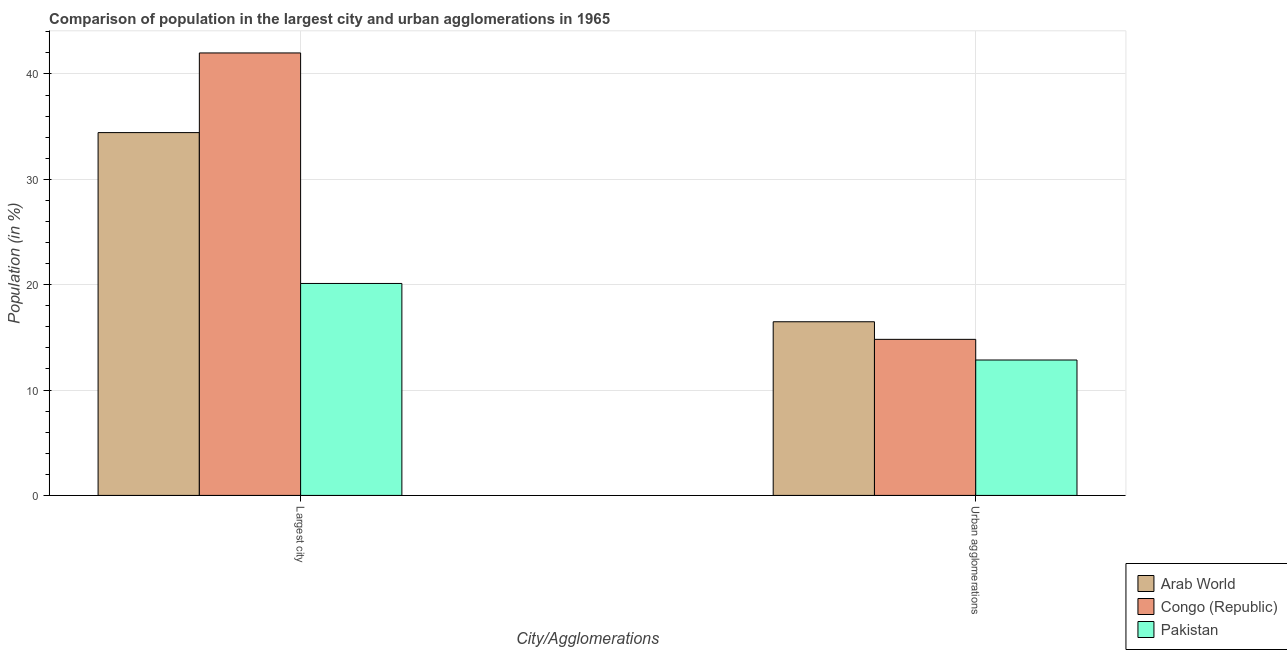How many different coloured bars are there?
Your answer should be compact. 3. How many bars are there on the 2nd tick from the left?
Provide a succinct answer. 3. What is the label of the 2nd group of bars from the left?
Provide a short and direct response. Urban agglomerations. What is the population in urban agglomerations in Pakistan?
Ensure brevity in your answer.  12.85. Across all countries, what is the maximum population in urban agglomerations?
Your answer should be very brief. 16.48. Across all countries, what is the minimum population in urban agglomerations?
Your answer should be very brief. 12.85. In which country was the population in the largest city maximum?
Ensure brevity in your answer.  Congo (Republic). What is the total population in urban agglomerations in the graph?
Make the answer very short. 44.15. What is the difference between the population in the largest city in Pakistan and that in Congo (Republic)?
Provide a short and direct response. -21.88. What is the difference between the population in the largest city in Pakistan and the population in urban agglomerations in Arab World?
Your response must be concise. 3.63. What is the average population in urban agglomerations per country?
Give a very brief answer. 14.72. What is the difference between the population in urban agglomerations and population in the largest city in Congo (Republic)?
Make the answer very short. -27.18. What is the ratio of the population in urban agglomerations in Arab World to that in Congo (Republic)?
Give a very brief answer. 1.11. Is the population in urban agglomerations in Pakistan less than that in Arab World?
Provide a succinct answer. Yes. What does the 1st bar from the left in Largest city represents?
Keep it short and to the point. Arab World. What does the 3rd bar from the right in Urban agglomerations represents?
Make the answer very short. Arab World. What is the difference between two consecutive major ticks on the Y-axis?
Provide a short and direct response. 10. Where does the legend appear in the graph?
Your answer should be compact. Bottom right. How many legend labels are there?
Offer a terse response. 3. How are the legend labels stacked?
Give a very brief answer. Vertical. What is the title of the graph?
Your response must be concise. Comparison of population in the largest city and urban agglomerations in 1965. Does "Thailand" appear as one of the legend labels in the graph?
Provide a short and direct response. No. What is the label or title of the X-axis?
Give a very brief answer. City/Agglomerations. What is the Population (in %) in Arab World in Largest city?
Give a very brief answer. 34.44. What is the Population (in %) of Congo (Republic) in Largest city?
Keep it short and to the point. 42. What is the Population (in %) in Pakistan in Largest city?
Provide a succinct answer. 20.12. What is the Population (in %) of Arab World in Urban agglomerations?
Your answer should be very brief. 16.48. What is the Population (in %) of Congo (Republic) in Urban agglomerations?
Keep it short and to the point. 14.81. What is the Population (in %) of Pakistan in Urban agglomerations?
Offer a terse response. 12.85. Across all City/Agglomerations, what is the maximum Population (in %) in Arab World?
Your answer should be very brief. 34.44. Across all City/Agglomerations, what is the maximum Population (in %) of Congo (Republic)?
Provide a short and direct response. 42. Across all City/Agglomerations, what is the maximum Population (in %) in Pakistan?
Offer a terse response. 20.12. Across all City/Agglomerations, what is the minimum Population (in %) in Arab World?
Ensure brevity in your answer.  16.48. Across all City/Agglomerations, what is the minimum Population (in %) in Congo (Republic)?
Make the answer very short. 14.81. Across all City/Agglomerations, what is the minimum Population (in %) of Pakistan?
Make the answer very short. 12.85. What is the total Population (in %) of Arab World in the graph?
Ensure brevity in your answer.  50.92. What is the total Population (in %) of Congo (Republic) in the graph?
Keep it short and to the point. 56.81. What is the total Population (in %) in Pakistan in the graph?
Keep it short and to the point. 32.97. What is the difference between the Population (in %) of Arab World in Largest city and that in Urban agglomerations?
Your answer should be very brief. 17.95. What is the difference between the Population (in %) in Congo (Republic) in Largest city and that in Urban agglomerations?
Give a very brief answer. 27.18. What is the difference between the Population (in %) in Pakistan in Largest city and that in Urban agglomerations?
Make the answer very short. 7.26. What is the difference between the Population (in %) of Arab World in Largest city and the Population (in %) of Congo (Republic) in Urban agglomerations?
Offer a very short reply. 19.62. What is the difference between the Population (in %) in Arab World in Largest city and the Population (in %) in Pakistan in Urban agglomerations?
Provide a succinct answer. 21.58. What is the difference between the Population (in %) in Congo (Republic) in Largest city and the Population (in %) in Pakistan in Urban agglomerations?
Offer a terse response. 29.14. What is the average Population (in %) of Arab World per City/Agglomerations?
Give a very brief answer. 25.46. What is the average Population (in %) of Congo (Republic) per City/Agglomerations?
Offer a terse response. 28.4. What is the average Population (in %) of Pakistan per City/Agglomerations?
Offer a very short reply. 16.49. What is the difference between the Population (in %) of Arab World and Population (in %) of Congo (Republic) in Largest city?
Your answer should be compact. -7.56. What is the difference between the Population (in %) in Arab World and Population (in %) in Pakistan in Largest city?
Make the answer very short. 14.32. What is the difference between the Population (in %) of Congo (Republic) and Population (in %) of Pakistan in Largest city?
Offer a very short reply. 21.88. What is the difference between the Population (in %) of Arab World and Population (in %) of Congo (Republic) in Urban agglomerations?
Your answer should be compact. 1.67. What is the difference between the Population (in %) of Arab World and Population (in %) of Pakistan in Urban agglomerations?
Provide a short and direct response. 3.63. What is the difference between the Population (in %) in Congo (Republic) and Population (in %) in Pakistan in Urban agglomerations?
Offer a very short reply. 1.96. What is the ratio of the Population (in %) of Arab World in Largest city to that in Urban agglomerations?
Your answer should be very brief. 2.09. What is the ratio of the Population (in %) in Congo (Republic) in Largest city to that in Urban agglomerations?
Offer a terse response. 2.83. What is the ratio of the Population (in %) of Pakistan in Largest city to that in Urban agglomerations?
Offer a terse response. 1.57. What is the difference between the highest and the second highest Population (in %) in Arab World?
Offer a very short reply. 17.95. What is the difference between the highest and the second highest Population (in %) in Congo (Republic)?
Give a very brief answer. 27.18. What is the difference between the highest and the second highest Population (in %) of Pakistan?
Offer a very short reply. 7.26. What is the difference between the highest and the lowest Population (in %) of Arab World?
Provide a short and direct response. 17.95. What is the difference between the highest and the lowest Population (in %) of Congo (Republic)?
Your answer should be compact. 27.18. What is the difference between the highest and the lowest Population (in %) of Pakistan?
Offer a terse response. 7.26. 